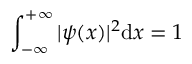Convert formula to latex. <formula><loc_0><loc_0><loc_500><loc_500>\int _ { - \infty } ^ { + \infty } | \psi ( x ) | ^ { 2 } d x = 1</formula> 